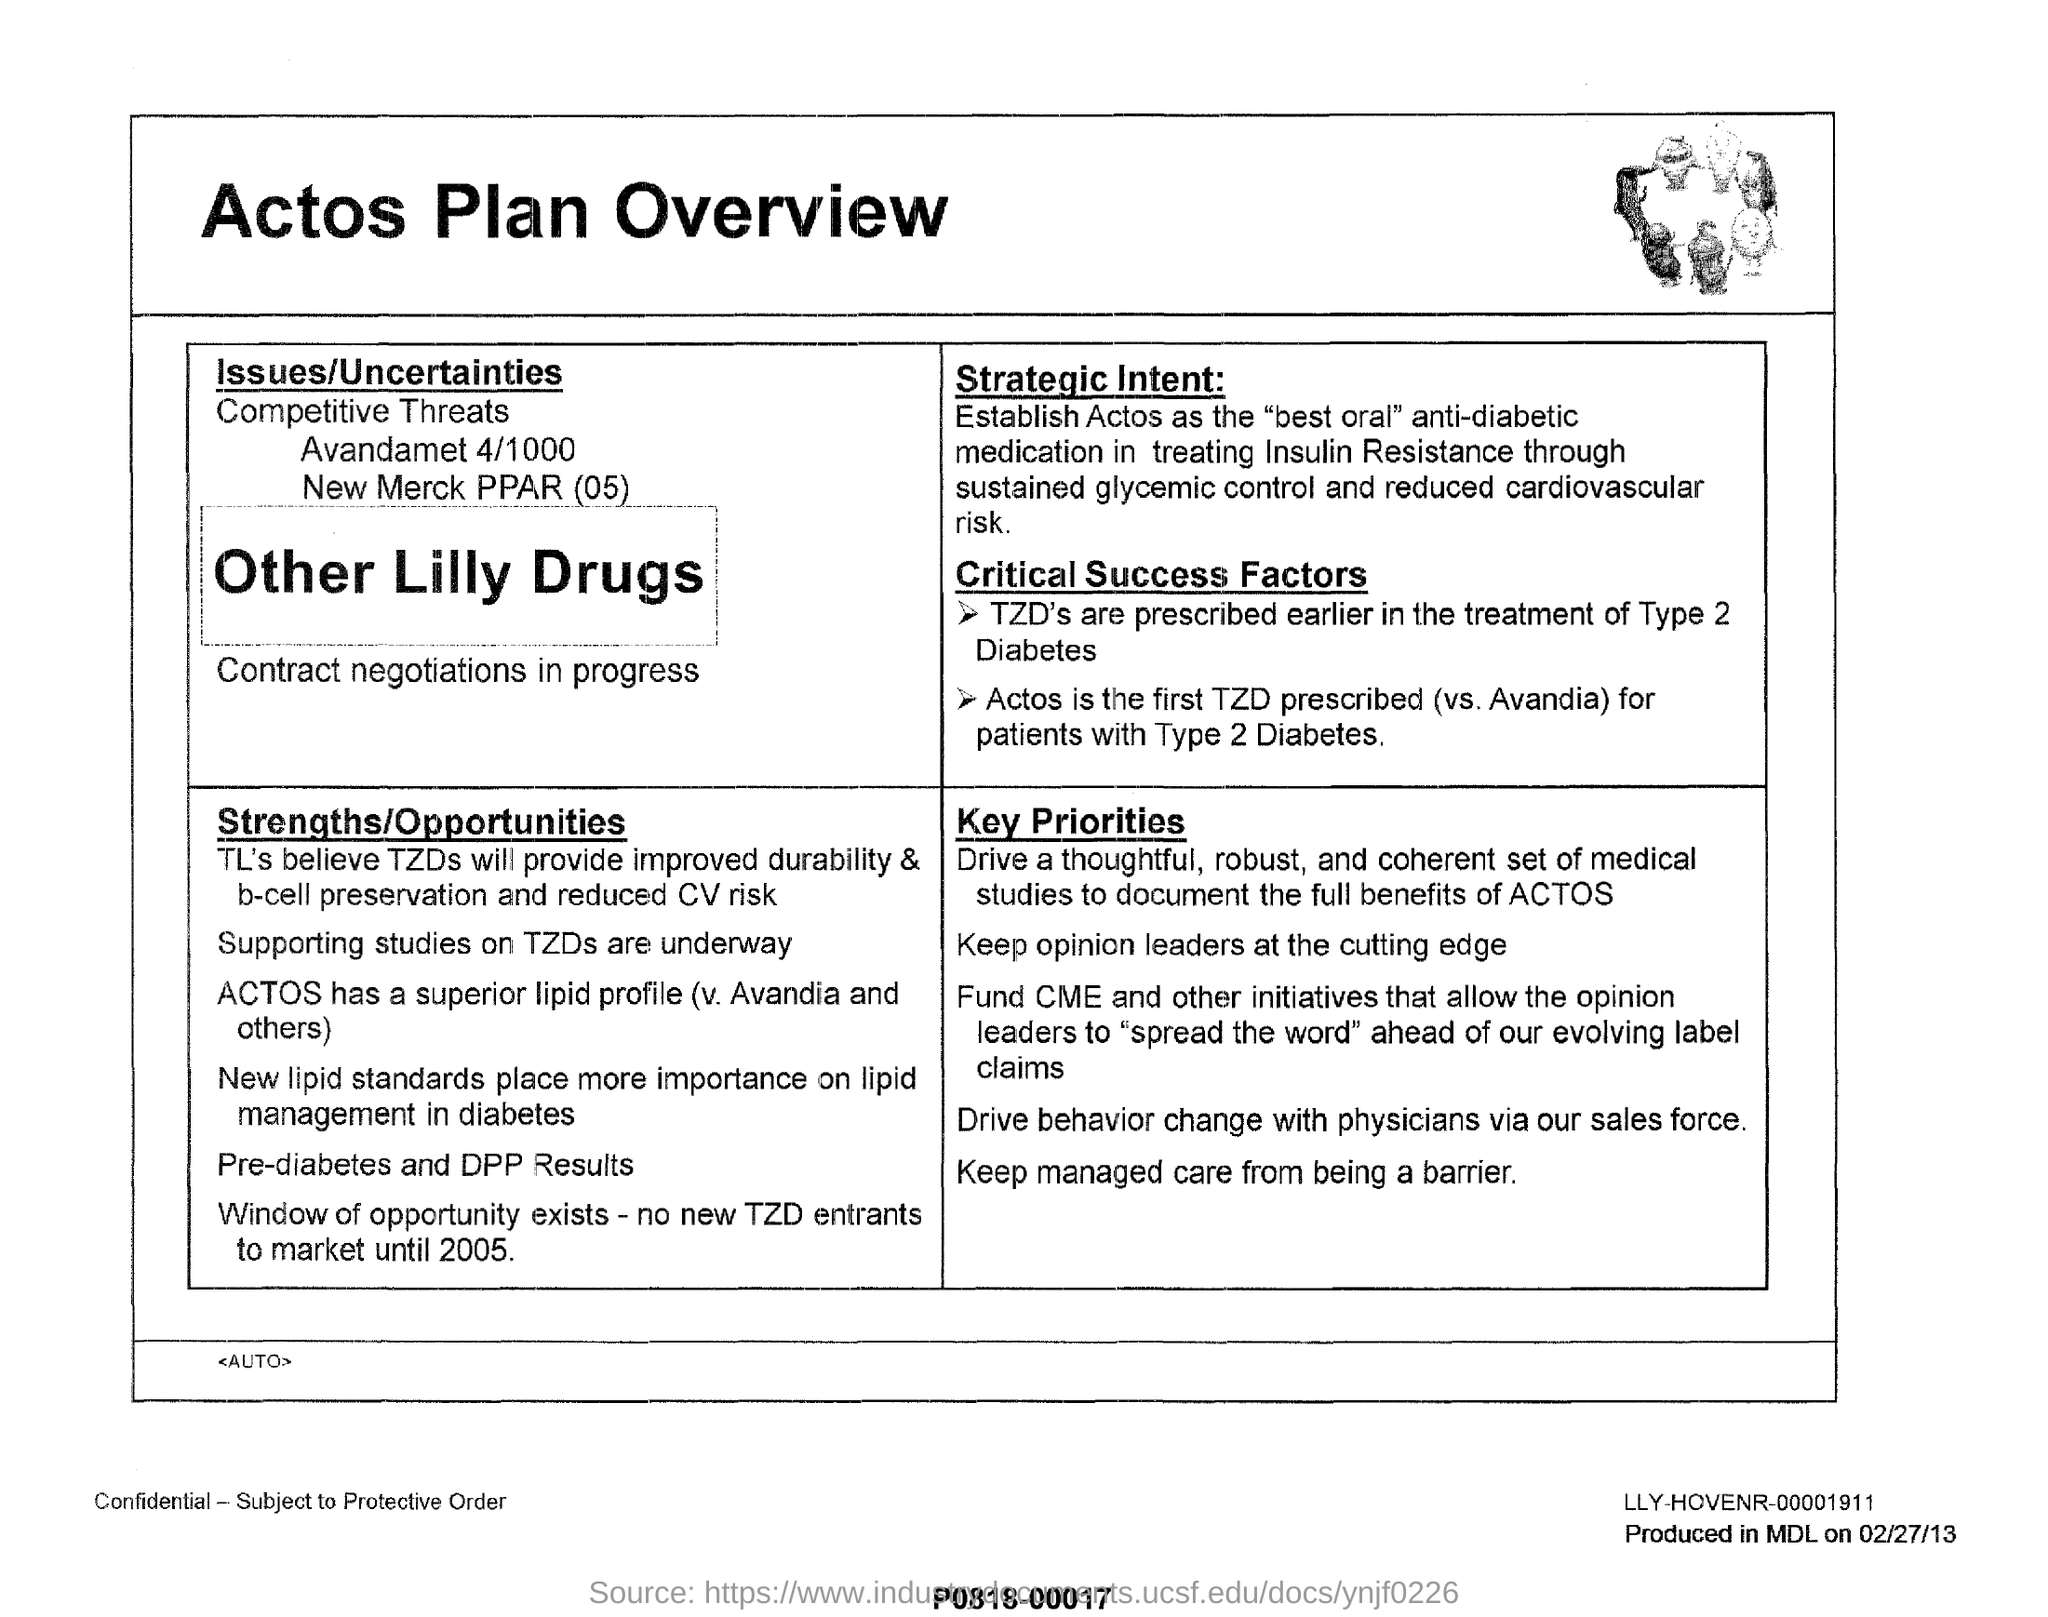What is the title of this page?
Provide a succinct answer. Actos plan overview. Which are prescibed eariler in the treatment of type 2 diabetes under the title of "critical success factors"?
Keep it short and to the point. TZD'S. Which has a superior lipid profile(v. avandia and others) under the title of "strength/opportunities?
Provide a short and direct response. ACTOS. 